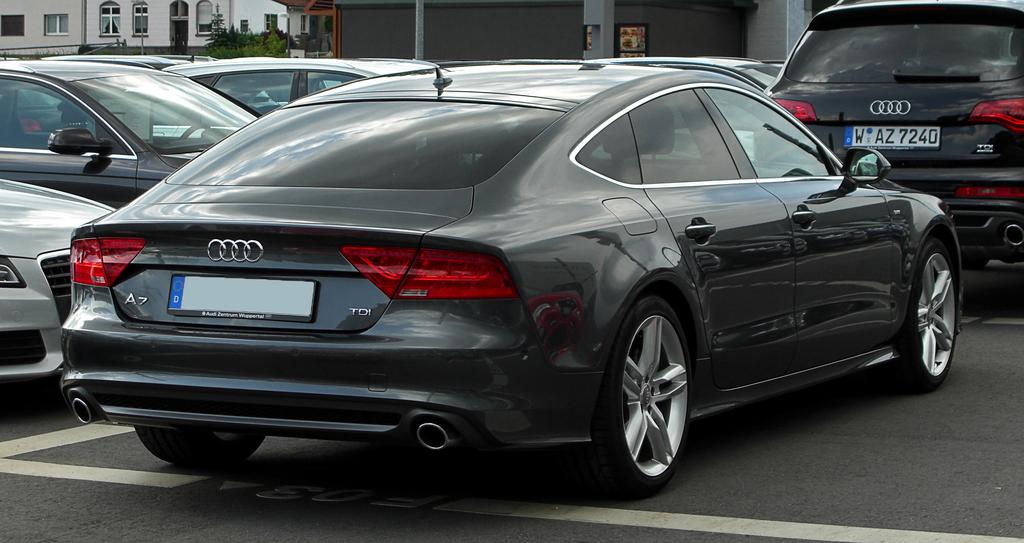Which version of car is that?
Provide a short and direct response. A7. What is the license plate number?
Give a very brief answer. Waz7240. 